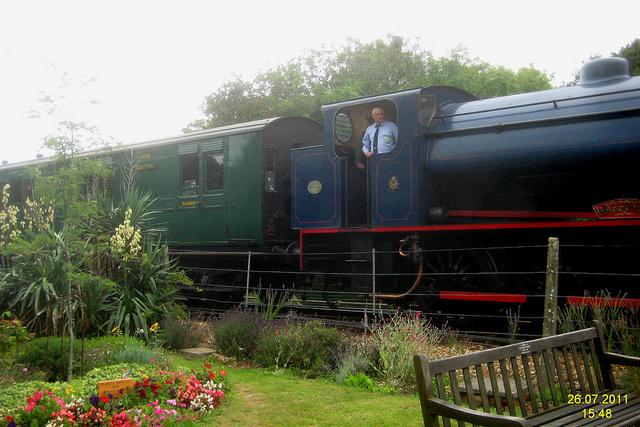What is the man wearing?

Choices:
A) tie
B) sunglasses
C) suspenders
D) backpack tie 